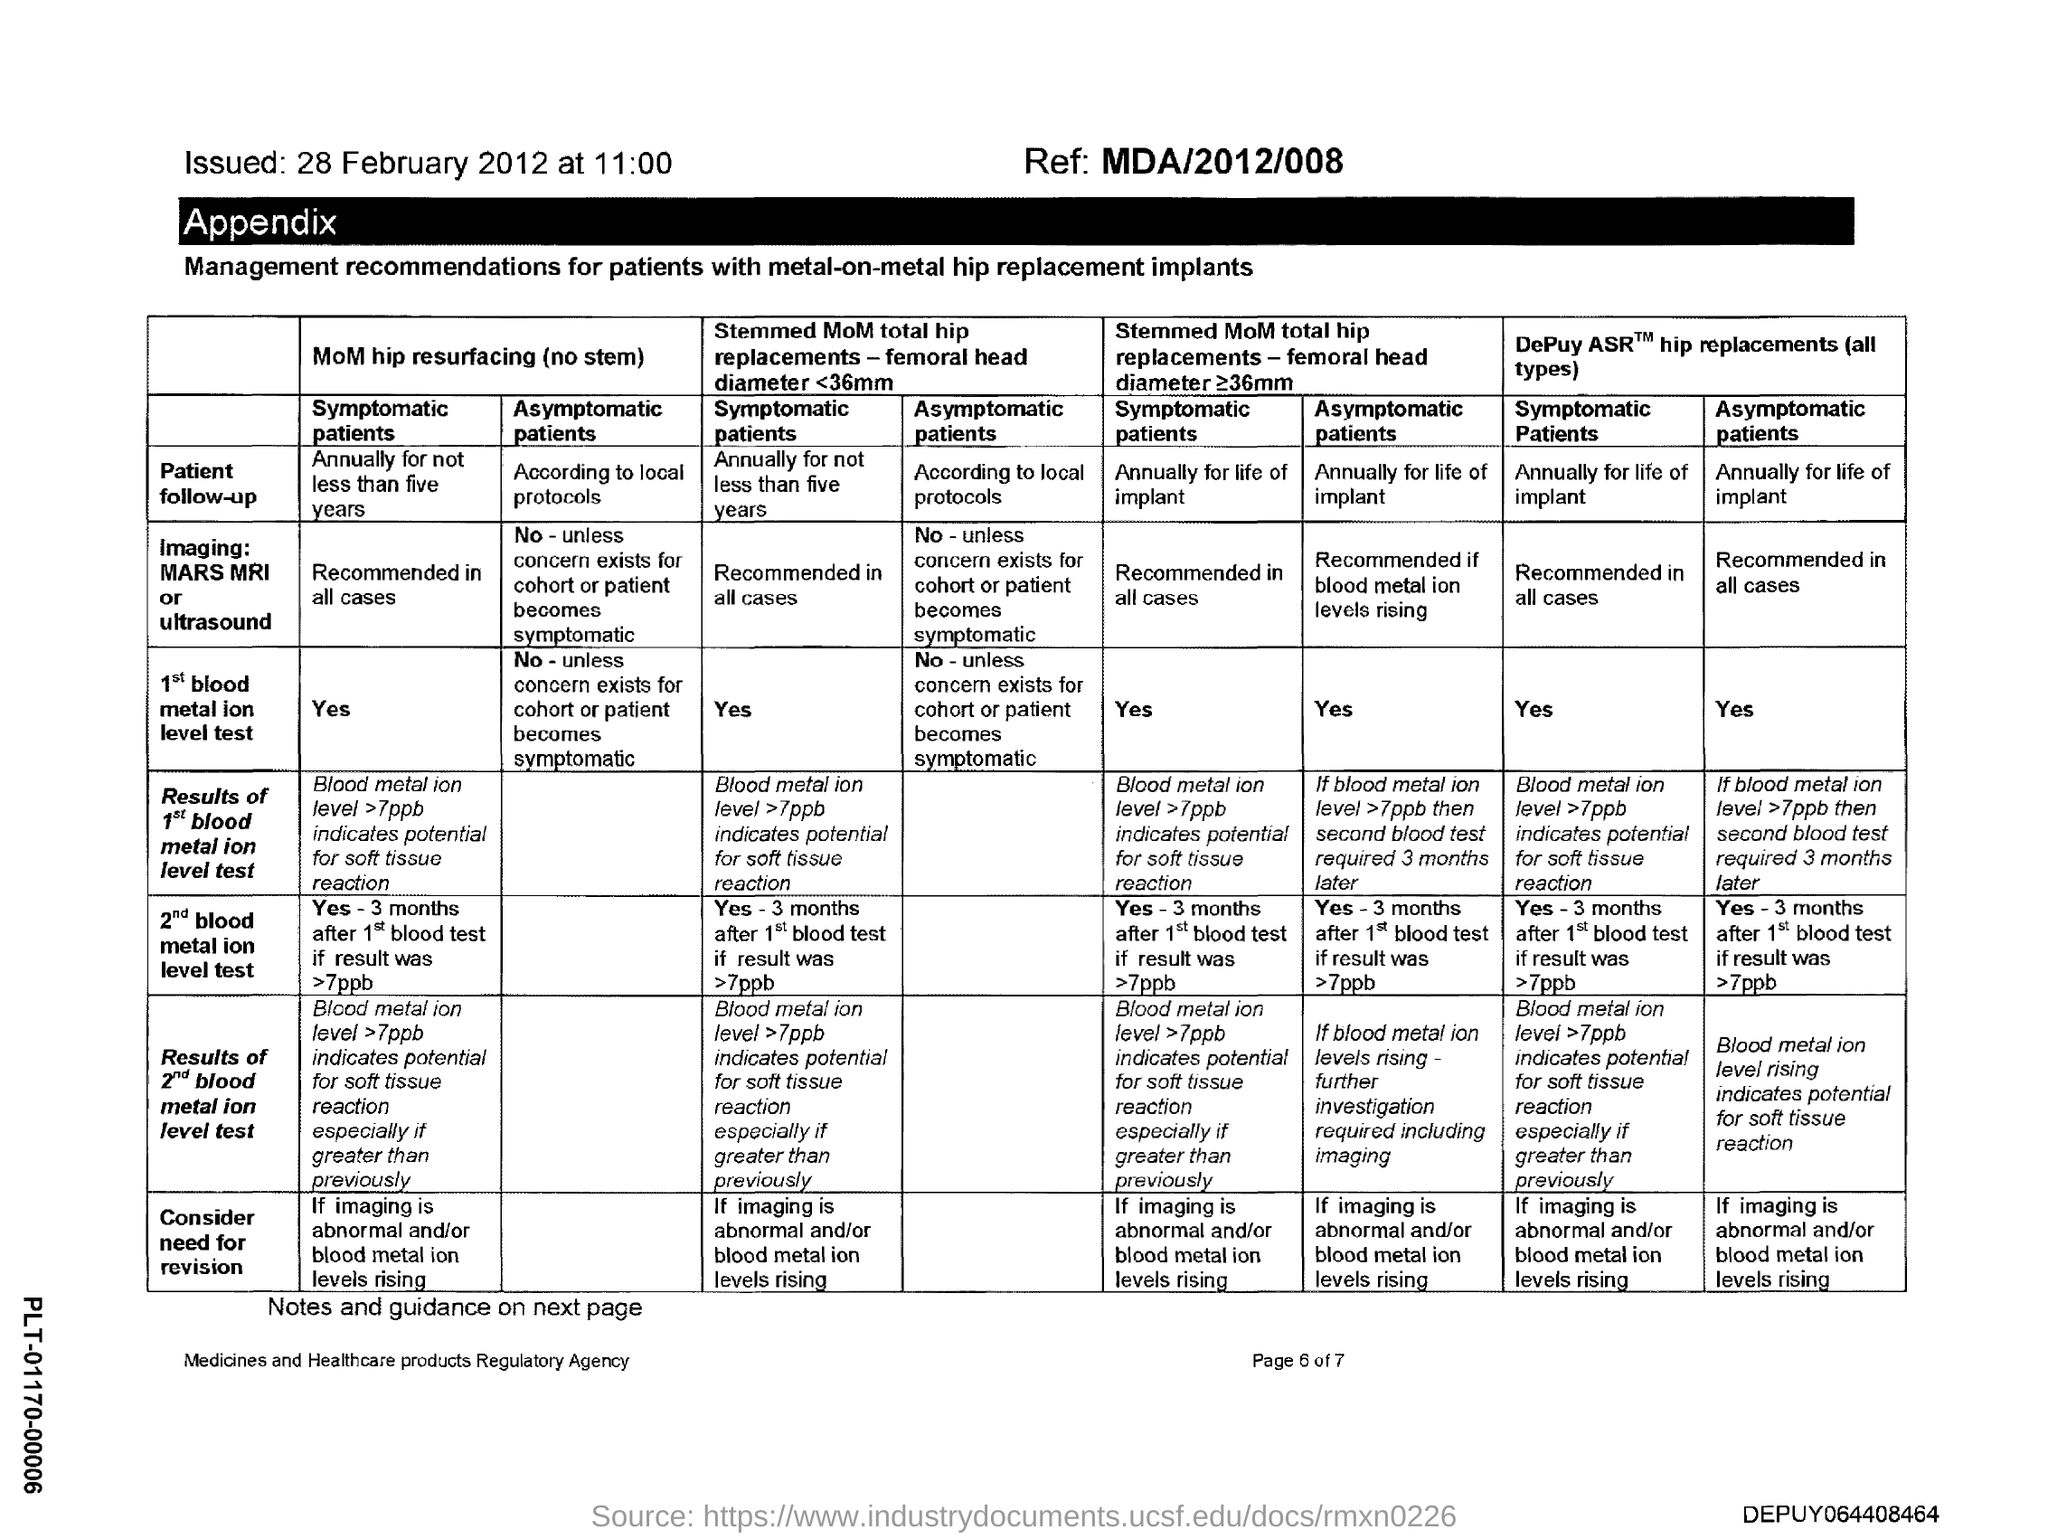What is the issued date?
Your answer should be very brief. 28 February 2012. What is the ref no.?
Your answer should be very brief. MDA/2012/008. 